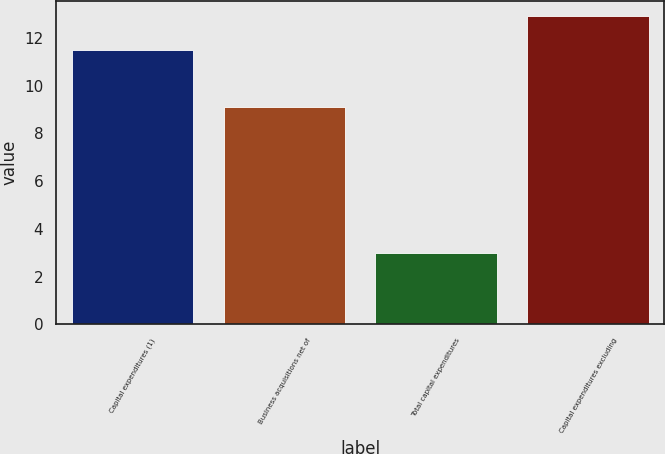Convert chart to OTSL. <chart><loc_0><loc_0><loc_500><loc_500><bar_chart><fcel>Capital expenditures (1)<fcel>Business acquisitions net of<fcel>Total capital expenditures<fcel>Capital expenditures excluding<nl><fcel>11.5<fcel>9.1<fcel>3<fcel>12.9<nl></chart> 